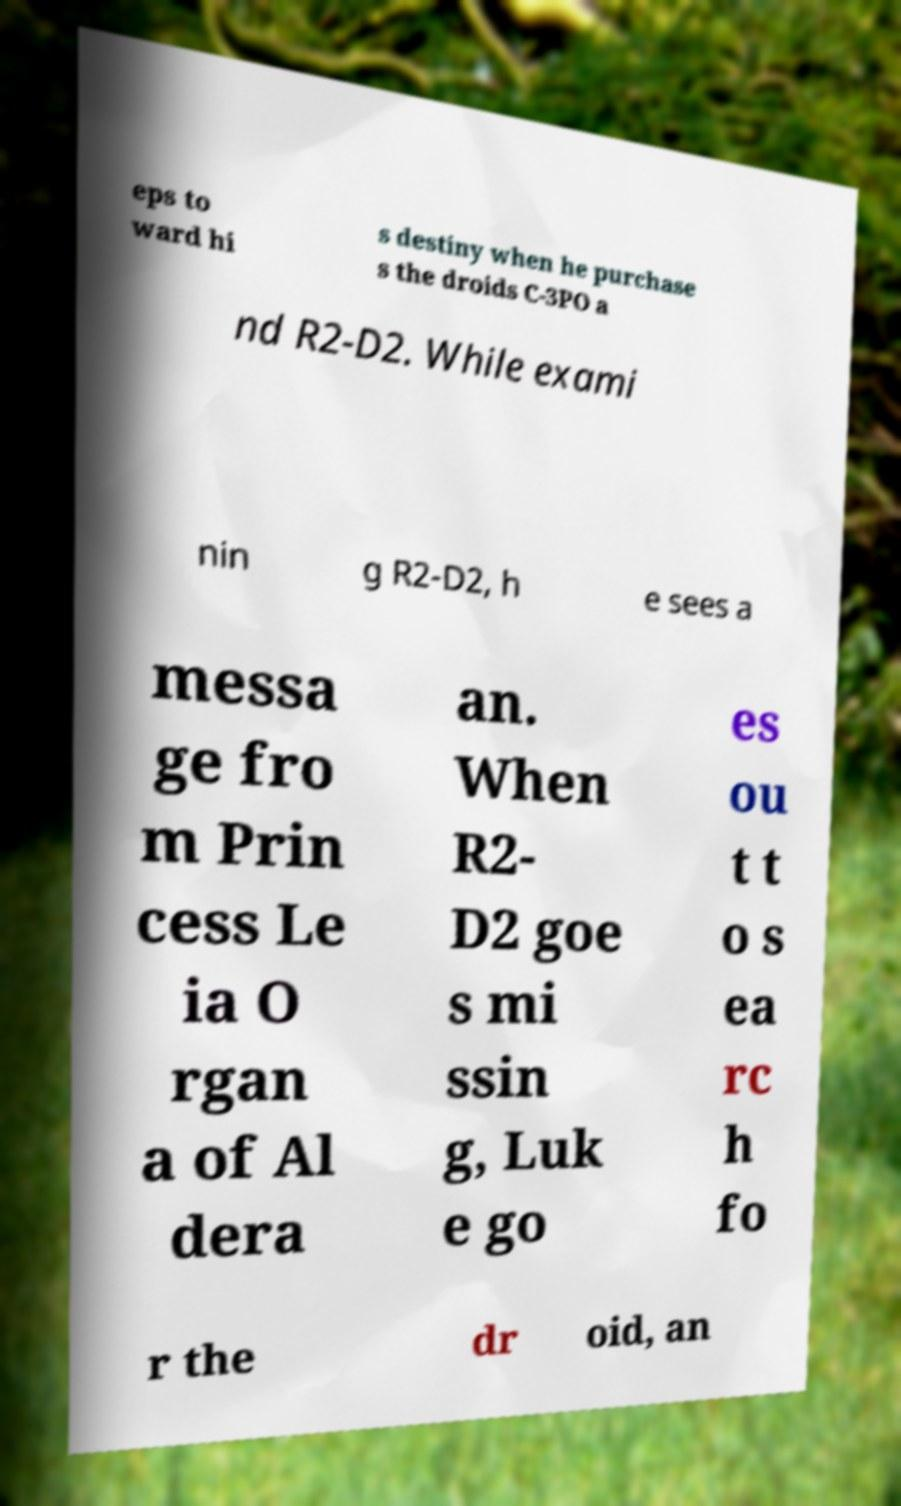There's text embedded in this image that I need extracted. Can you transcribe it verbatim? eps to ward hi s destiny when he purchase s the droids C-3PO a nd R2-D2. While exami nin g R2-D2, h e sees a messa ge fro m Prin cess Le ia O rgan a of Al dera an. When R2- D2 goe s mi ssin g, Luk e go es ou t t o s ea rc h fo r the dr oid, an 